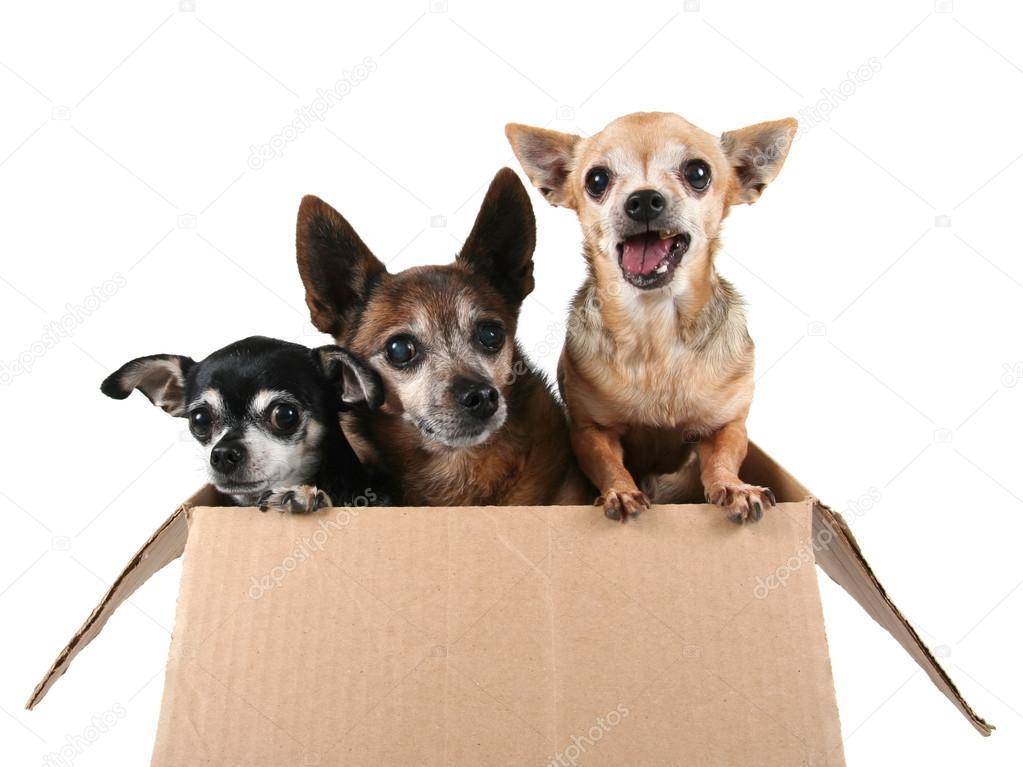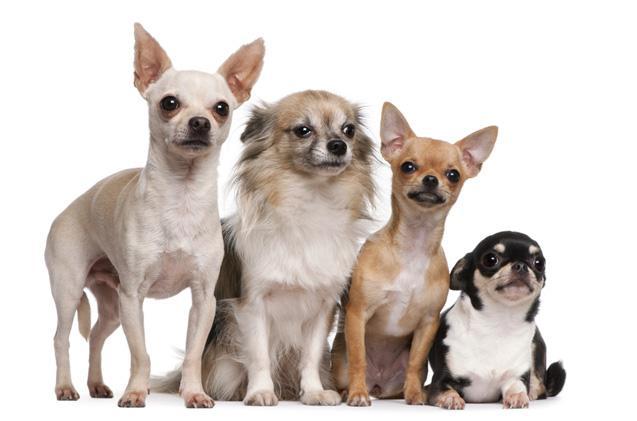The first image is the image on the left, the second image is the image on the right. For the images displayed, is the sentence "One image contains three small dogs, and the other image contains four small dogs." factually correct? Answer yes or no. Yes. 